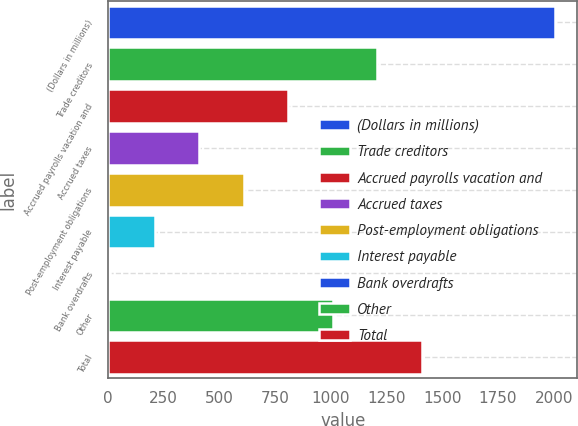Convert chart. <chart><loc_0><loc_0><loc_500><loc_500><bar_chart><fcel>(Dollars in millions)<fcel>Trade creditors<fcel>Accrued payrolls vacation and<fcel>Accrued taxes<fcel>Post-employment obligations<fcel>Interest payable<fcel>Bank overdrafts<fcel>Other<fcel>Total<nl><fcel>2006<fcel>1208<fcel>809<fcel>410<fcel>609.5<fcel>210.5<fcel>11<fcel>1008.5<fcel>1407.5<nl></chart> 